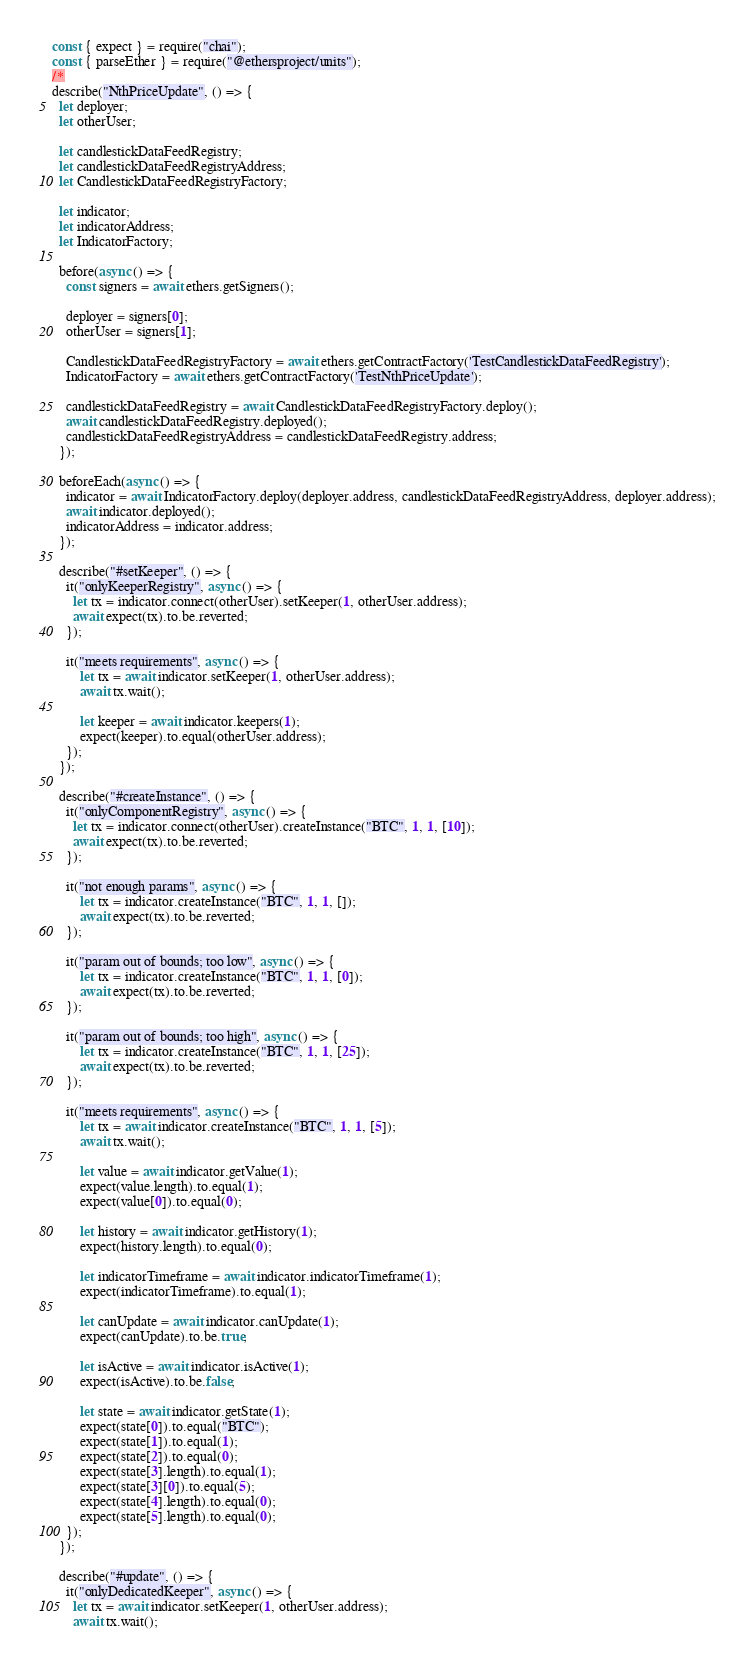Convert code to text. <code><loc_0><loc_0><loc_500><loc_500><_JavaScript_>const { expect } = require("chai");
const { parseEther } = require("@ethersproject/units");
/*
describe("NthPriceUpdate", () => {
  let deployer;
  let otherUser;

  let candlestickDataFeedRegistry;
  let candlestickDataFeedRegistryAddress;
  let CandlestickDataFeedRegistryFactory;

  let indicator;
  let indicatorAddress;
  let IndicatorFactory;

  before(async () => {
    const signers = await ethers.getSigners();

    deployer = signers[0];
    otherUser = signers[1];

    CandlestickDataFeedRegistryFactory = await ethers.getContractFactory('TestCandlestickDataFeedRegistry');
    IndicatorFactory = await ethers.getContractFactory('TestNthPriceUpdate');

    candlestickDataFeedRegistry = await CandlestickDataFeedRegistryFactory.deploy();
    await candlestickDataFeedRegistry.deployed();
    candlestickDataFeedRegistryAddress = candlestickDataFeedRegistry.address;
  });

  beforeEach(async () => {
    indicator = await IndicatorFactory.deploy(deployer.address, candlestickDataFeedRegistryAddress, deployer.address);
    await indicator.deployed();
    indicatorAddress = indicator.address;
  });
  
  describe("#setKeeper", () => {
    it("onlyKeeperRegistry", async () => {
      let tx = indicator.connect(otherUser).setKeeper(1, otherUser.address);
      await expect(tx).to.be.reverted;
    });

    it("meets requirements", async () => {
        let tx = await indicator.setKeeper(1, otherUser.address);
        await tx.wait();

        let keeper = await indicator.keepers(1);
        expect(keeper).to.equal(otherUser.address);
    });
  });

  describe("#createInstance", () => {
    it("onlyComponentRegistry", async () => {
      let tx = indicator.connect(otherUser).createInstance("BTC", 1, 1, [10]);
      await expect(tx).to.be.reverted;
    });

    it("not enough params", async () => {
        let tx = indicator.createInstance("BTC", 1, 1, []);
        await expect(tx).to.be.reverted;
    });

    it("param out of bounds; too low", async () => {
        let tx = indicator.createInstance("BTC", 1, 1, [0]);
        await expect(tx).to.be.reverted;
    });

    it("param out of bounds; too high", async () => {
        let tx = indicator.createInstance("BTC", 1, 1, [25]);
        await expect(tx).to.be.reverted;
    });

    it("meets requirements", async () => {
        let tx = await indicator.createInstance("BTC", 1, 1, [5]);
        await tx.wait();

        let value = await indicator.getValue(1);
        expect(value.length).to.equal(1);
        expect(value[0]).to.equal(0);

        let history = await indicator.getHistory(1);
        expect(history.length).to.equal(0);

        let indicatorTimeframe = await indicator.indicatorTimeframe(1);
        expect(indicatorTimeframe).to.equal(1);

        let canUpdate = await indicator.canUpdate(1);
        expect(canUpdate).to.be.true;

        let isActive = await indicator.isActive(1);
        expect(isActive).to.be.false;

        let state = await indicator.getState(1);
        expect(state[0]).to.equal("BTC");
        expect(state[1]).to.equal(1);
        expect(state[2]).to.equal(0);
        expect(state[3].length).to.equal(1);
        expect(state[3][0]).to.equal(5);
        expect(state[4].length).to.equal(0);
        expect(state[5].length).to.equal(0);
    });
  });

  describe("#update", () => {
    it("onlyDedicatedKeeper", async () => {
      let tx = await indicator.setKeeper(1, otherUser.address);
      await tx.wait();
</code> 